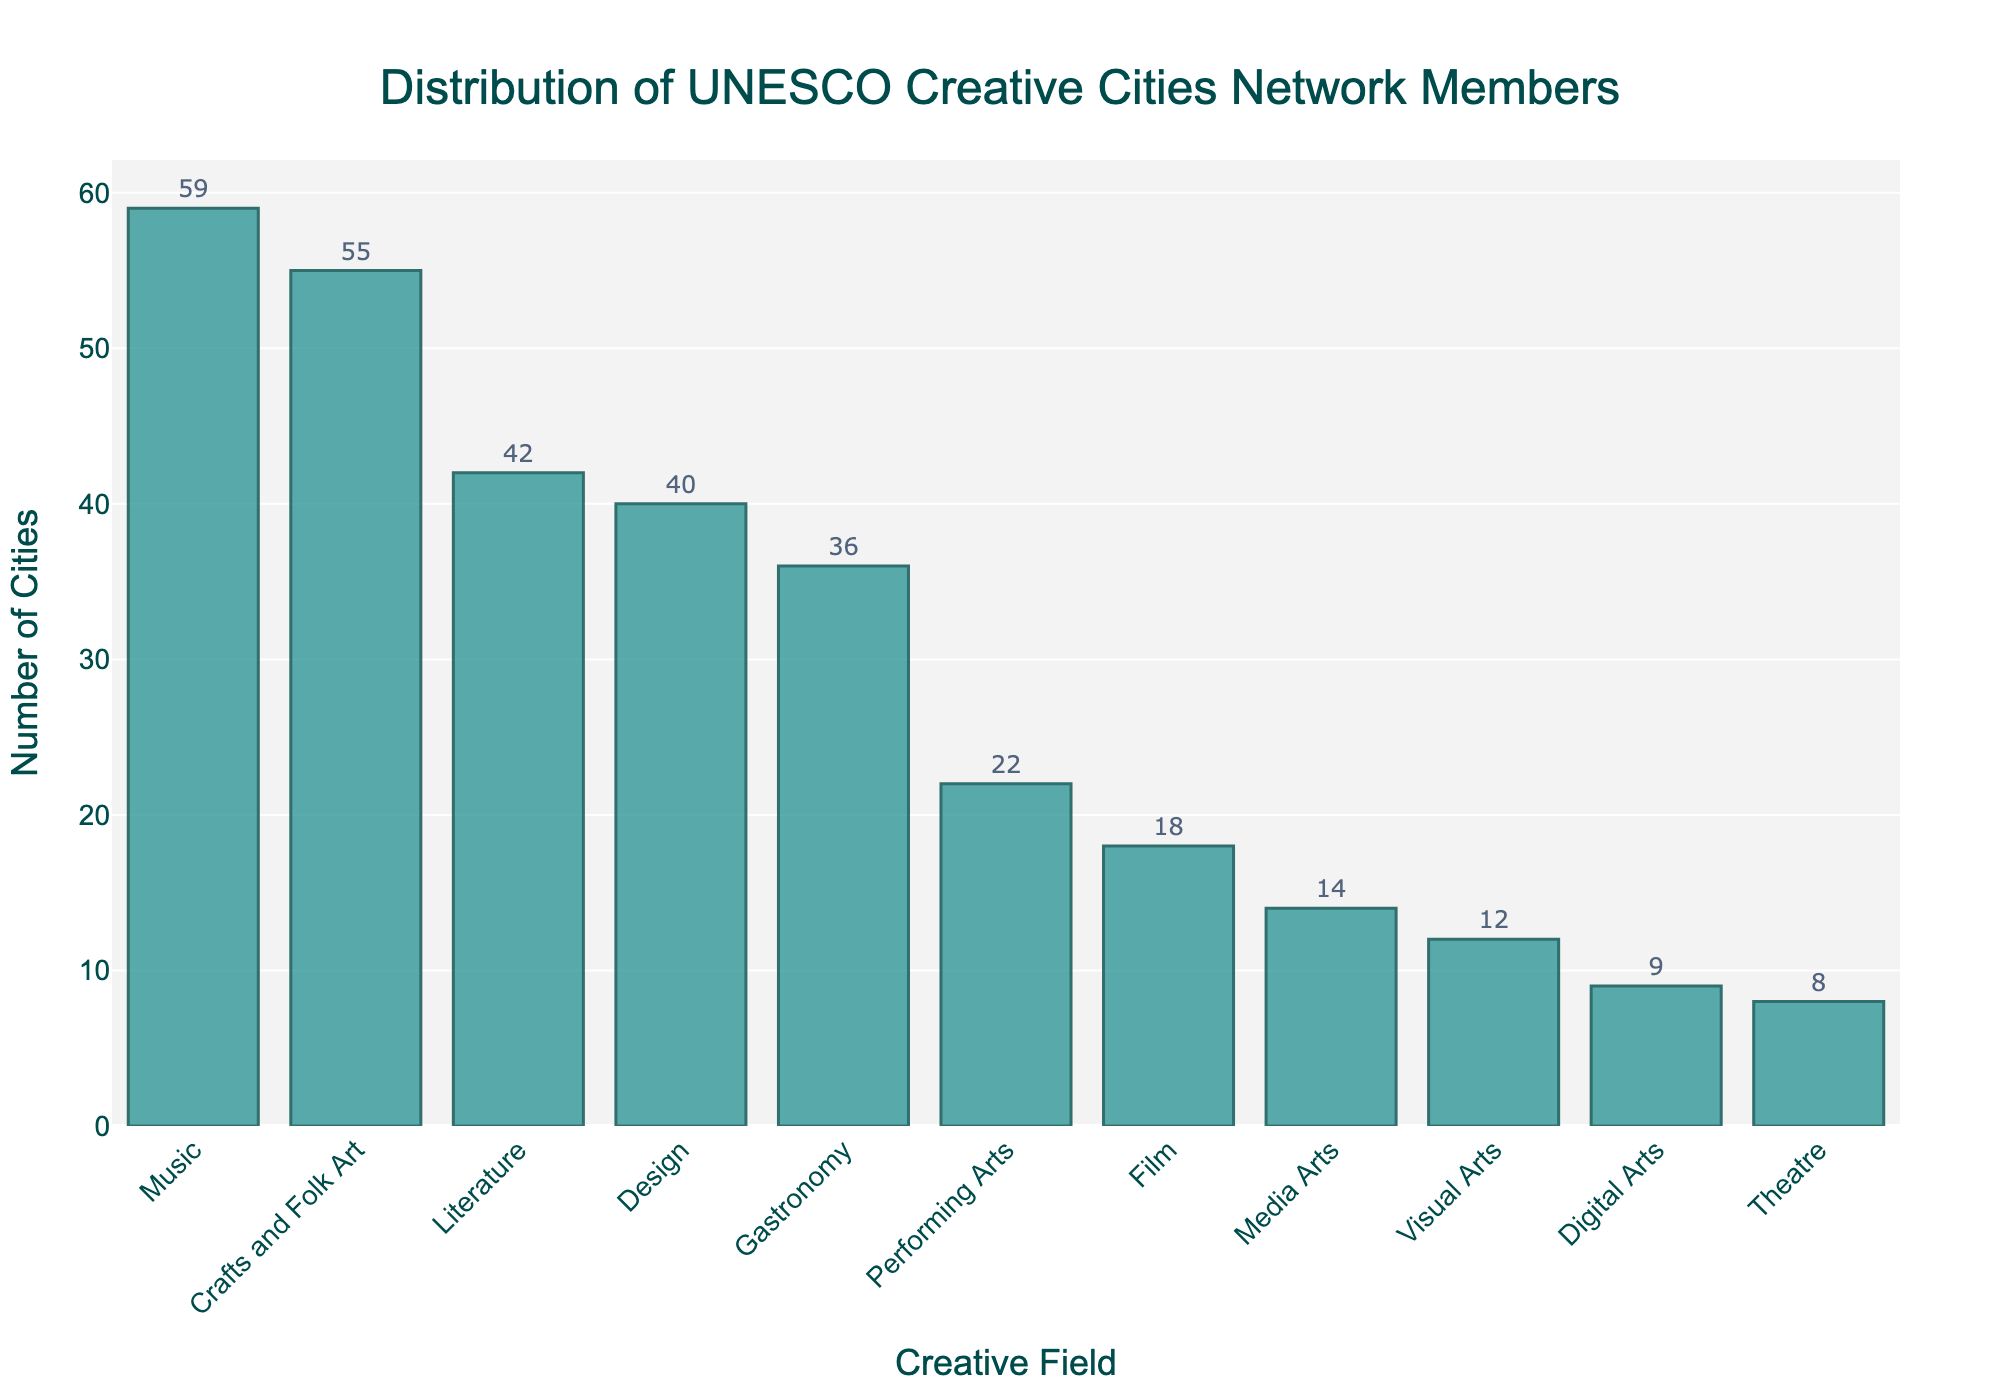Which creative field has the highest number of cities? Look for the tallest bar in the chart, which represents the creative field with the highest number of cities.
Answer: Music Which creative field has the lowest number of cities? Look for the shortest bar in the chart, which represents the creative field with the lowest number of cities.
Answer: Theatre How many more cities are associated with Music compared to Media Arts? Find the heights of the bars for Music and Media Arts. Subtract the number of cities in Media Arts from the number of cities in Music: 59 - 14 = 45.
Answer: 45 Are there more cities associated with Crafts and Folk Art or Gastronomy? Compare the heights of the bars for Crafts and Folk Art and Gastronomy. Crafts and Folk Art has a taller bar than Gastronomy.
Answer: Crafts and Folk Art What is the combined number of cities for Literature, Film, and Design? Sum the number of cities for Literature, Film, and Design: 42 (Literature) + 18 (Film) + 40 (Design) = 100.
Answer: 100 Which two creative fields have the closest number of cities? Compare the heights of the bars visually to see which two bars are nearly the same height. Literature (42) and Design (40) are the closest.
Answer: Literature and Design How many cities are there in total for all the creative fields? Sum the number of cities for all creative fields: 42 + 18 + 59 + 55 + 40 + 14 + 36 + 9 + 12 + 22 + 8 = 315.
Answer: 315 Is the number of cities in Performing Arts greater than or less than the number of cities in Media Arts? Compare the heights of the bars for Performing Arts and Media Arts. The bar for Performing Arts is taller than the bar for Media Arts.
Answer: Greater What is the average number of cities across all creative fields? Calculate the sum of the total number of cities and divide by the number of creative fields: (42 + 18 + 59 + 55 + 40 + 14 + 36 + 9 + 12 + 22 + 8) / 11 = 28.64.
Answer: 28.64 Which creative fields have fewer than 15 cities associated with them? Identify the bars with heights representing less than 15 cities: Media Arts (14), Digital Arts (9), Theatre (8), Visual Arts (12).
Answer: Media Arts, Digital Arts, Theatre, Visual Arts 